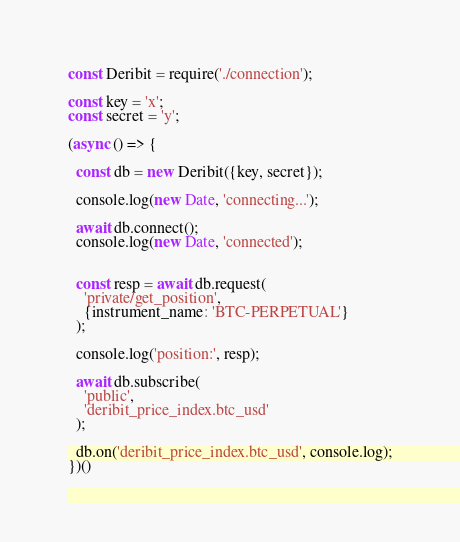<code> <loc_0><loc_0><loc_500><loc_500><_JavaScript_>const Deribit = require('./connection');

const key = 'x';
const secret = 'y';

(async () => {

  const db = new Deribit({key, secret});

  console.log(new Date, 'connecting...');

  await db.connect();
  console.log(new Date, 'connected');
  

  const resp = await db.request(
    'private/get_position',
    {instrument_name: 'BTC-PERPETUAL'}
  );

  console.log('position:', resp);

  await db.subscribe(
    'public',
    'deribit_price_index.btc_usd'
  );

  db.on('deribit_price_index.btc_usd', console.log);
})()</code> 